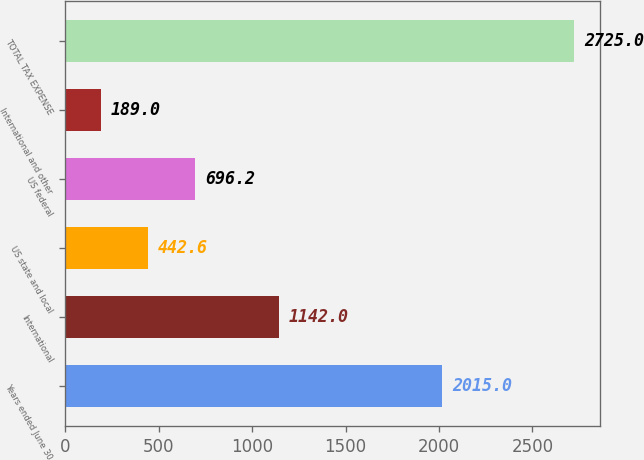Convert chart. <chart><loc_0><loc_0><loc_500><loc_500><bar_chart><fcel>Years ended June 30<fcel>International<fcel>US state and local<fcel>US federal<fcel>International and other<fcel>TOTAL TAX EXPENSE<nl><fcel>2015<fcel>1142<fcel>442.6<fcel>696.2<fcel>189<fcel>2725<nl></chart> 